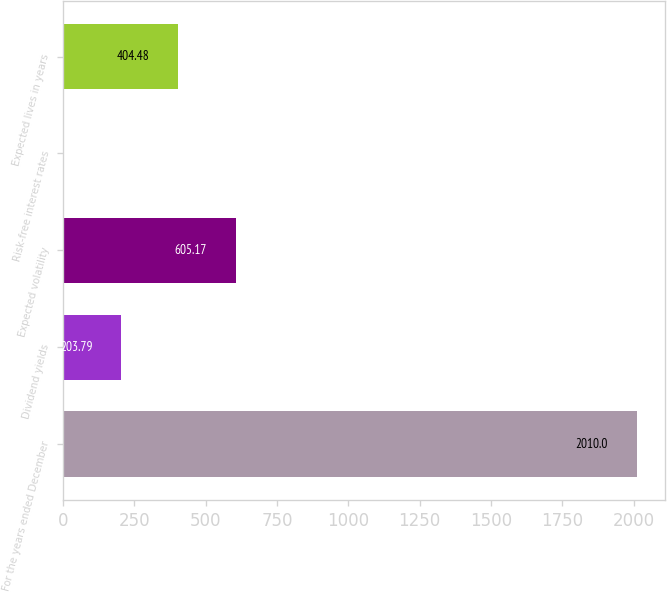<chart> <loc_0><loc_0><loc_500><loc_500><bar_chart><fcel>For the years ended December<fcel>Dividend yields<fcel>Expected volatility<fcel>Risk-free interest rates<fcel>Expected lives in years<nl><fcel>2010<fcel>203.79<fcel>605.17<fcel>3.1<fcel>404.48<nl></chart> 